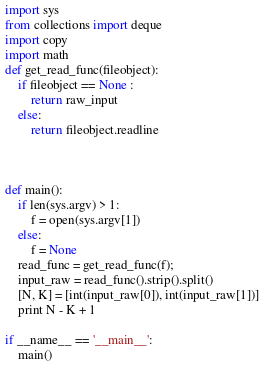<code> <loc_0><loc_0><loc_500><loc_500><_Python_>import sys
from collections import deque
import copy
import math
def get_read_func(fileobject):
    if fileobject == None :
        return raw_input
    else:
        return fileobject.readline



def main():
    if len(sys.argv) > 1:
        f = open(sys.argv[1])
    else:
        f = None
    read_func = get_read_func(f);
    input_raw = read_func().strip().split()
    [N, K] = [int(input_raw[0]), int(input_raw[1])]
    print N - K + 1

if __name__ == '__main__':
    main()
</code> 